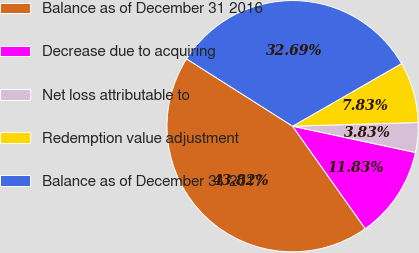Convert chart to OTSL. <chart><loc_0><loc_0><loc_500><loc_500><pie_chart><fcel>Balance as of December 31 2016<fcel>Decrease due to acquiring<fcel>Net loss attributable to<fcel>Redemption value adjustment<fcel>Balance as of December 31 2017<nl><fcel>43.83%<fcel>11.83%<fcel>3.83%<fcel>7.83%<fcel>32.7%<nl></chart> 